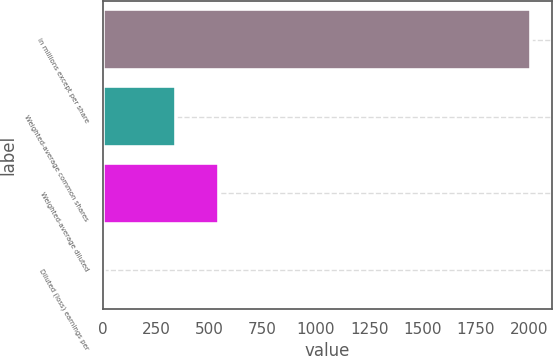Convert chart to OTSL. <chart><loc_0><loc_0><loc_500><loc_500><bar_chart><fcel>in millions except per share<fcel>Weighted-average common shares<fcel>Weighted-average diluted<fcel>Diluted (loss) earnings per<nl><fcel>2006<fcel>345.7<fcel>545.85<fcel>4.51<nl></chart> 